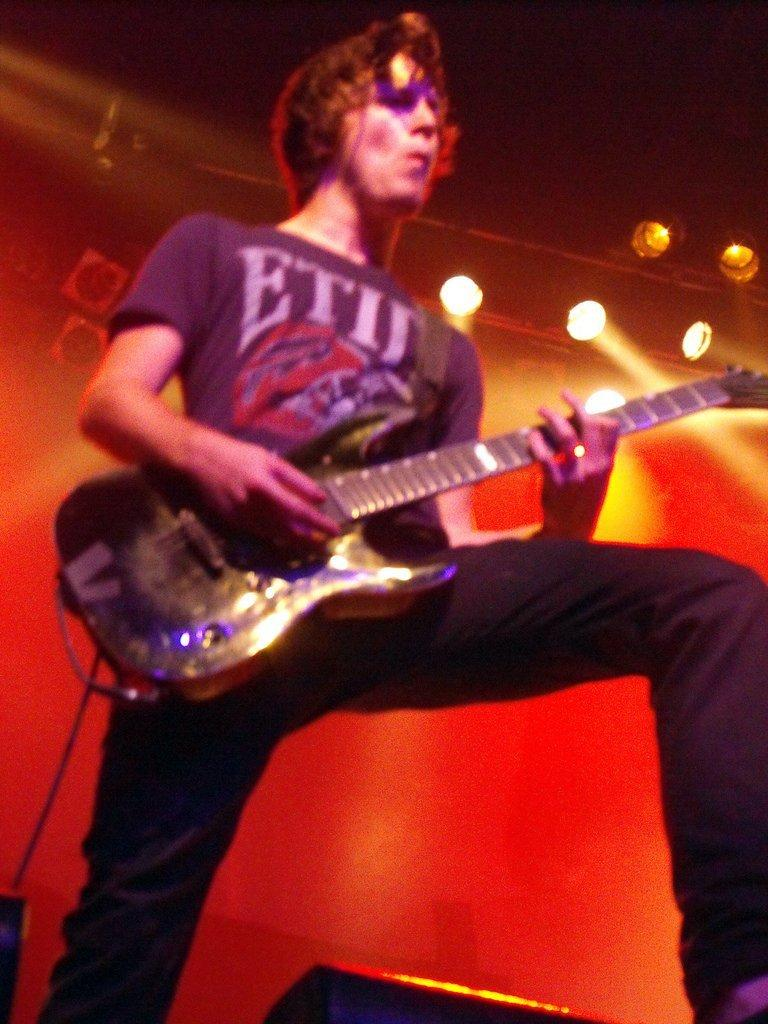What can be seen in the image that produces light? There are lights in the image. Who is present in the image? There is a man in the image. What is the man holding in the image? The man is holding a guitar. Can you see any boats in the image? There is no boat present in the image. What type of lettuce is being used as a prop in the image? There is no lettuce present in the image. 